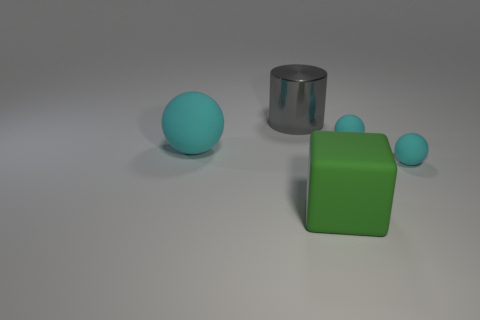Add 1 tiny yellow blocks. How many objects exist? 6 Subtract all large cyan balls. How many balls are left? 2 Subtract all cylinders. How many objects are left? 4 Subtract 2 balls. How many balls are left? 1 Subtract all gray blocks. Subtract all yellow balls. How many blocks are left? 1 Subtract all tiny yellow shiny balls. Subtract all rubber spheres. How many objects are left? 2 Add 2 green objects. How many green objects are left? 3 Add 5 large metallic things. How many large metallic things exist? 6 Subtract 1 cyan spheres. How many objects are left? 4 